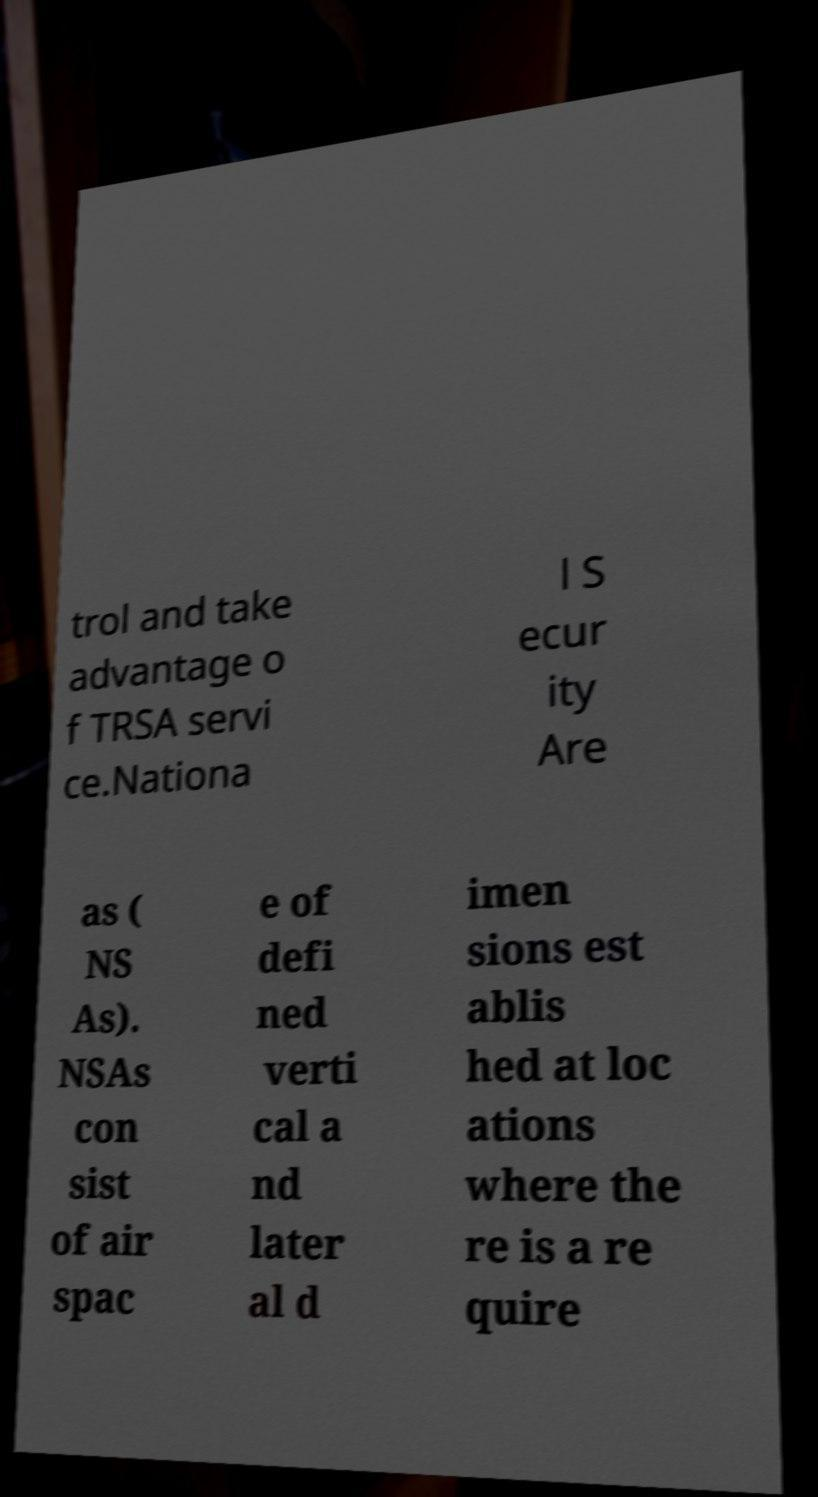Please identify and transcribe the text found in this image. trol and take advantage o f TRSA servi ce.Nationa l S ecur ity Are as ( NS As). NSAs con sist of air spac e of defi ned verti cal a nd later al d imen sions est ablis hed at loc ations where the re is a re quire 